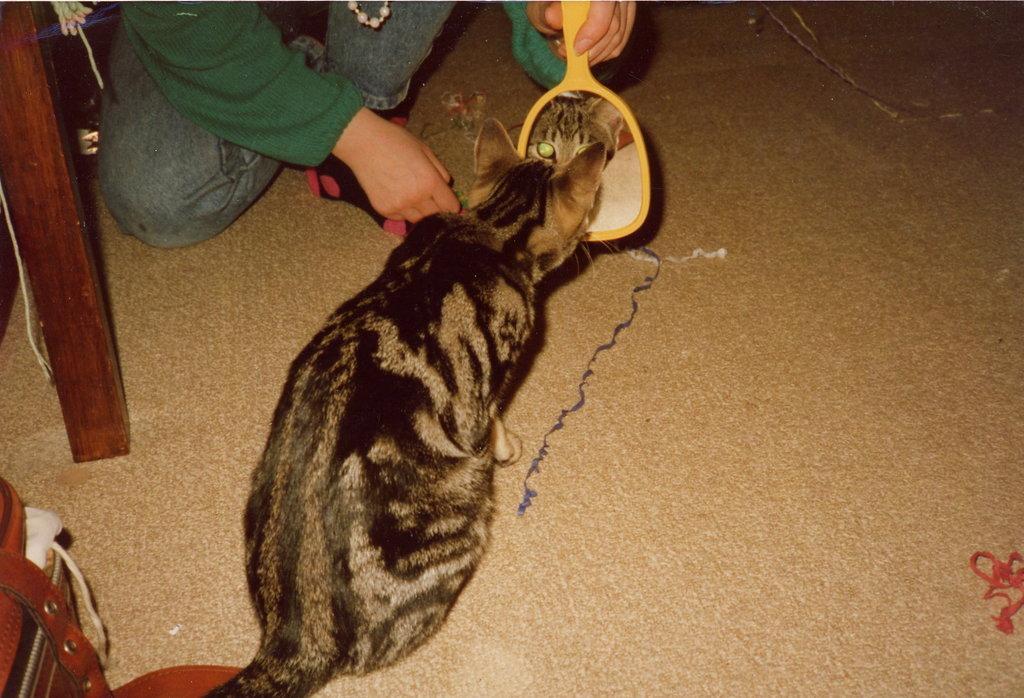Describe this image in one or two sentences. In this image we can see a cat and a person holding a mirror, in the mirror, we can see a reflection of a cat and there are some objects on the floor. 